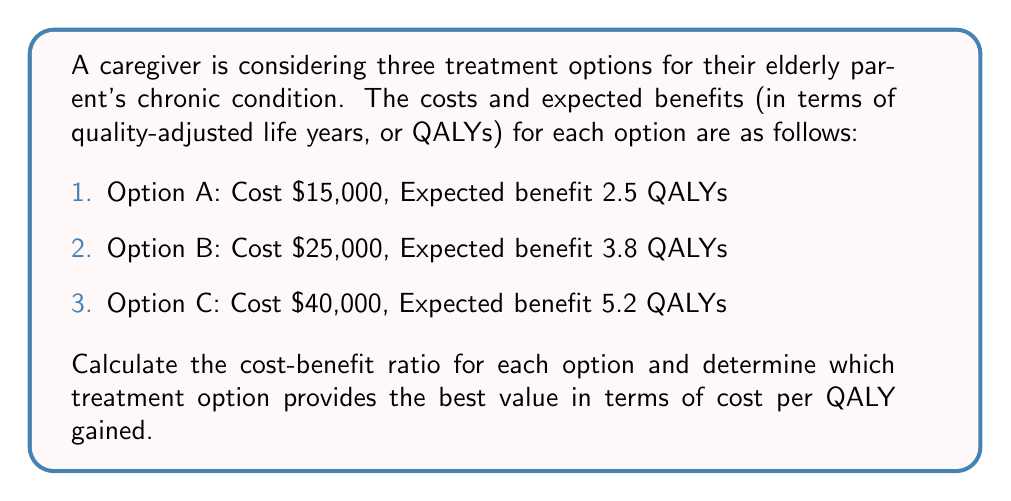Show me your answer to this math problem. To solve this problem, we need to calculate the cost-benefit ratio for each treatment option. The cost-benefit ratio is calculated by dividing the cost by the expected benefit (QALYs).

Let's calculate the ratio for each option:

1. Option A:
   Cost-benefit ratio = $\frac{\text{Cost}}{\text{Expected Benefit}}$
   $$ \text{Ratio}_A = \frac{\$15,000}{2.5 \text{ QALYs}} = \$6,000 \text{ per QALY} $$

2. Option B:
   $$ \text{Ratio}_B = \frac{\$25,000}{3.8 \text{ QALYs}} = \$6,578.95 \text{ per QALY} $$

3. Option C:
   $$ \text{Ratio}_C = \frac{\$40,000}{5.2 \text{ QALYs}} = \$7,692.31 \text{ per QALY} $$

The lower the cost per QALY, the better the value of the treatment option. Comparing the ratios:

$\text{Ratio}_A < \text{Ratio}_B < \text{Ratio}_C$

Therefore, Option A provides the best value in terms of cost per QALY gained.
Answer: Option A provides the best value with a cost-benefit ratio of $6,000 per QALY. 